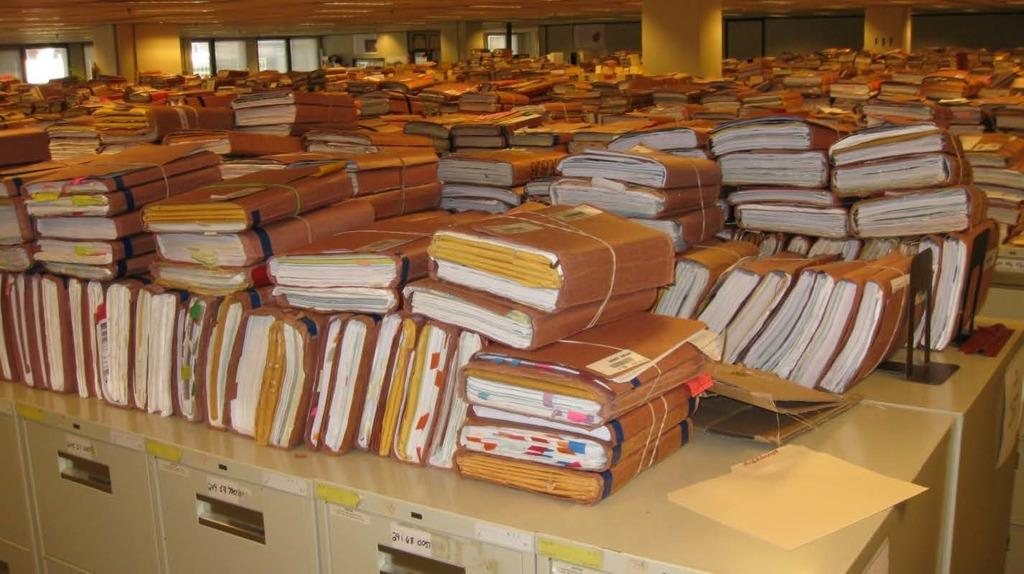What is arranged on the tables in the image? There are files arranged on the tables. What can be seen in the background of the image? There are pillars, a wall, and windows in the background of the image. What type of joke can be seen written on the wall in the image? There is no joke written on the wall in the image; it only shows files, pillars, a wall, and windows. 